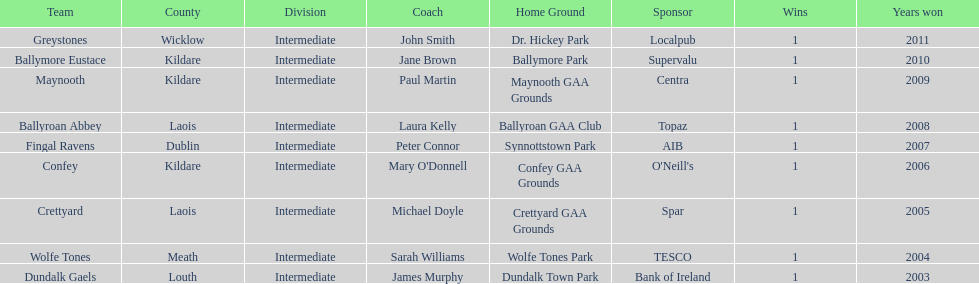What is the years won for each team 2011, 2010, 2009, 2008, 2007, 2006, 2005, 2004, 2003. 